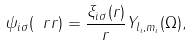<formula> <loc_0><loc_0><loc_500><loc_500>\psi _ { i \sigma } ( \ r r ) = \frac { \xi _ { i \sigma } ( r ) } { r } Y _ { l _ { i } , m _ { i } } ( \Omega ) ,</formula> 